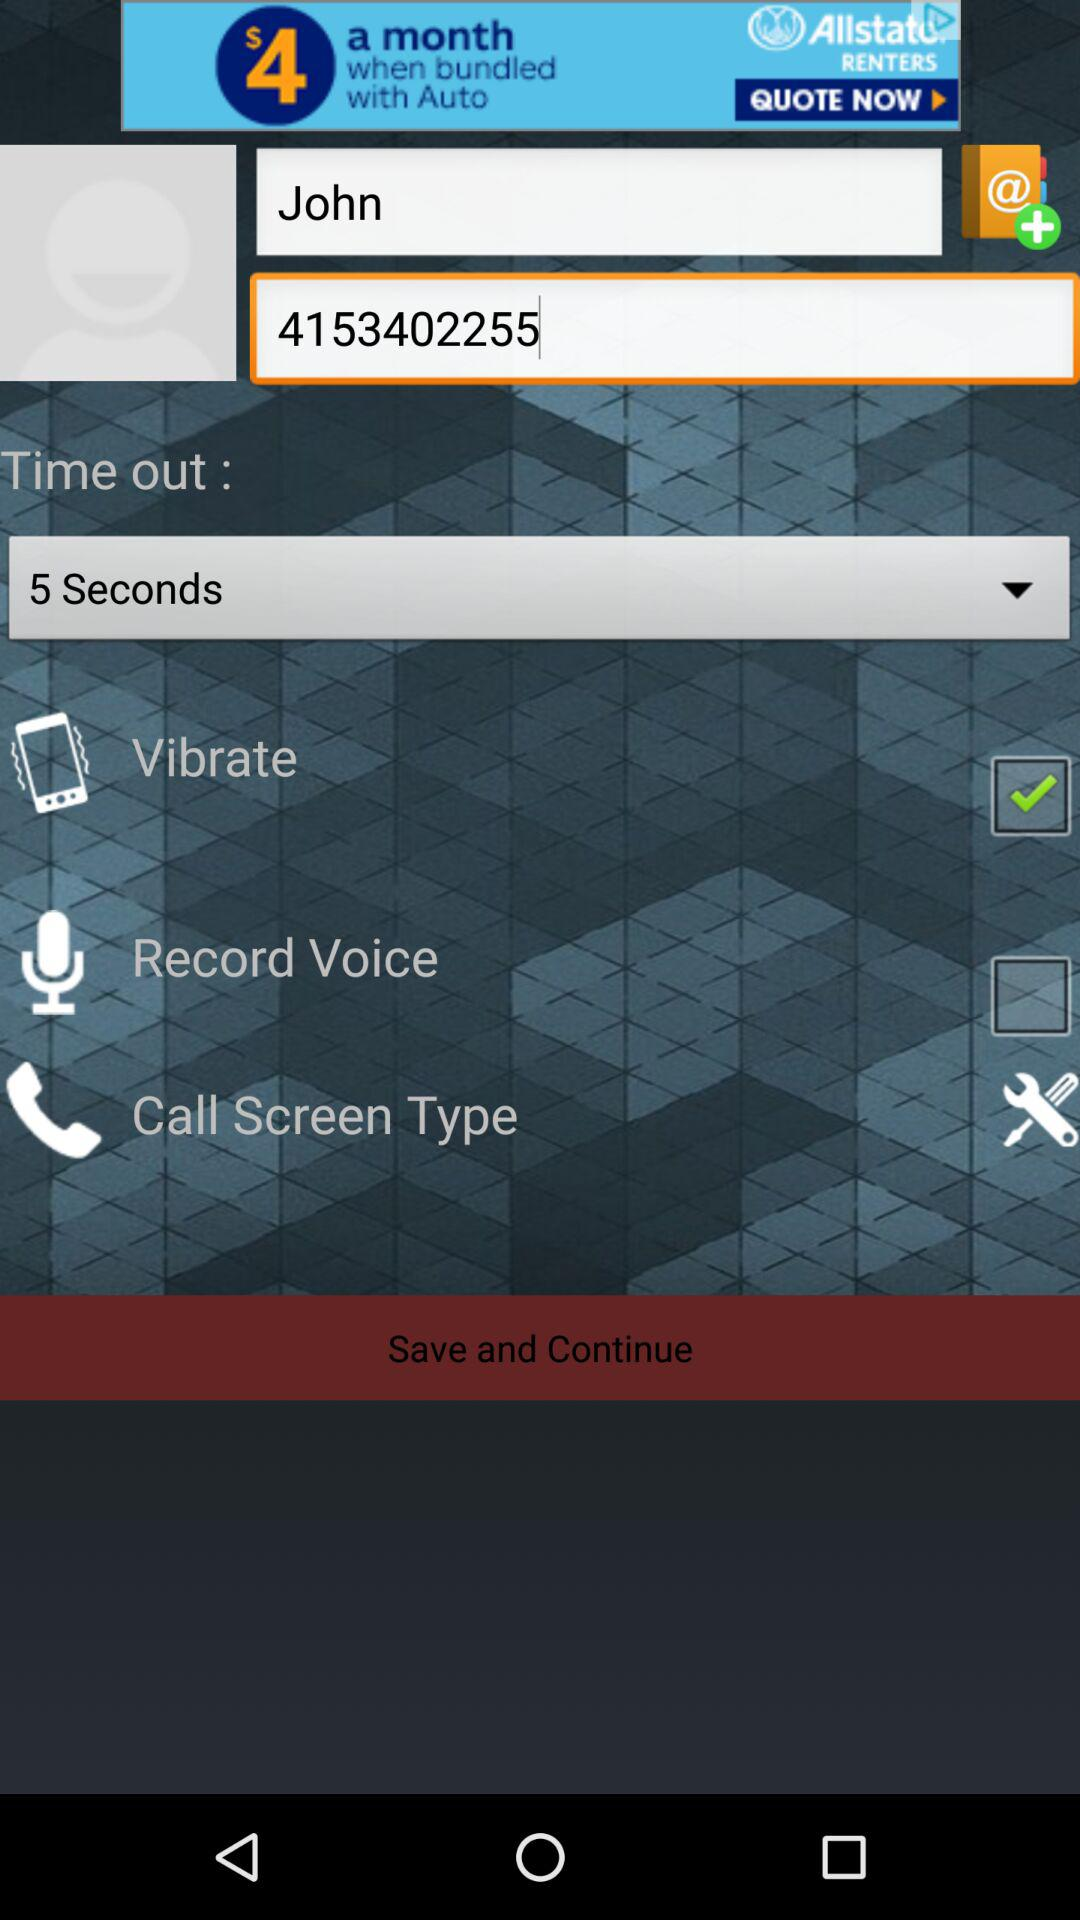What is John's phone number? John's phone number is 4153402255. 